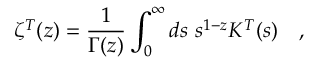Convert formula to latex. <formula><loc_0><loc_0><loc_500><loc_500>\zeta ^ { T } ( z ) = { \frac { 1 } { \Gamma ( z ) } } \int _ { 0 } ^ { \infty } d s s ^ { 1 - z } K ^ { T } ( s ) ,</formula> 